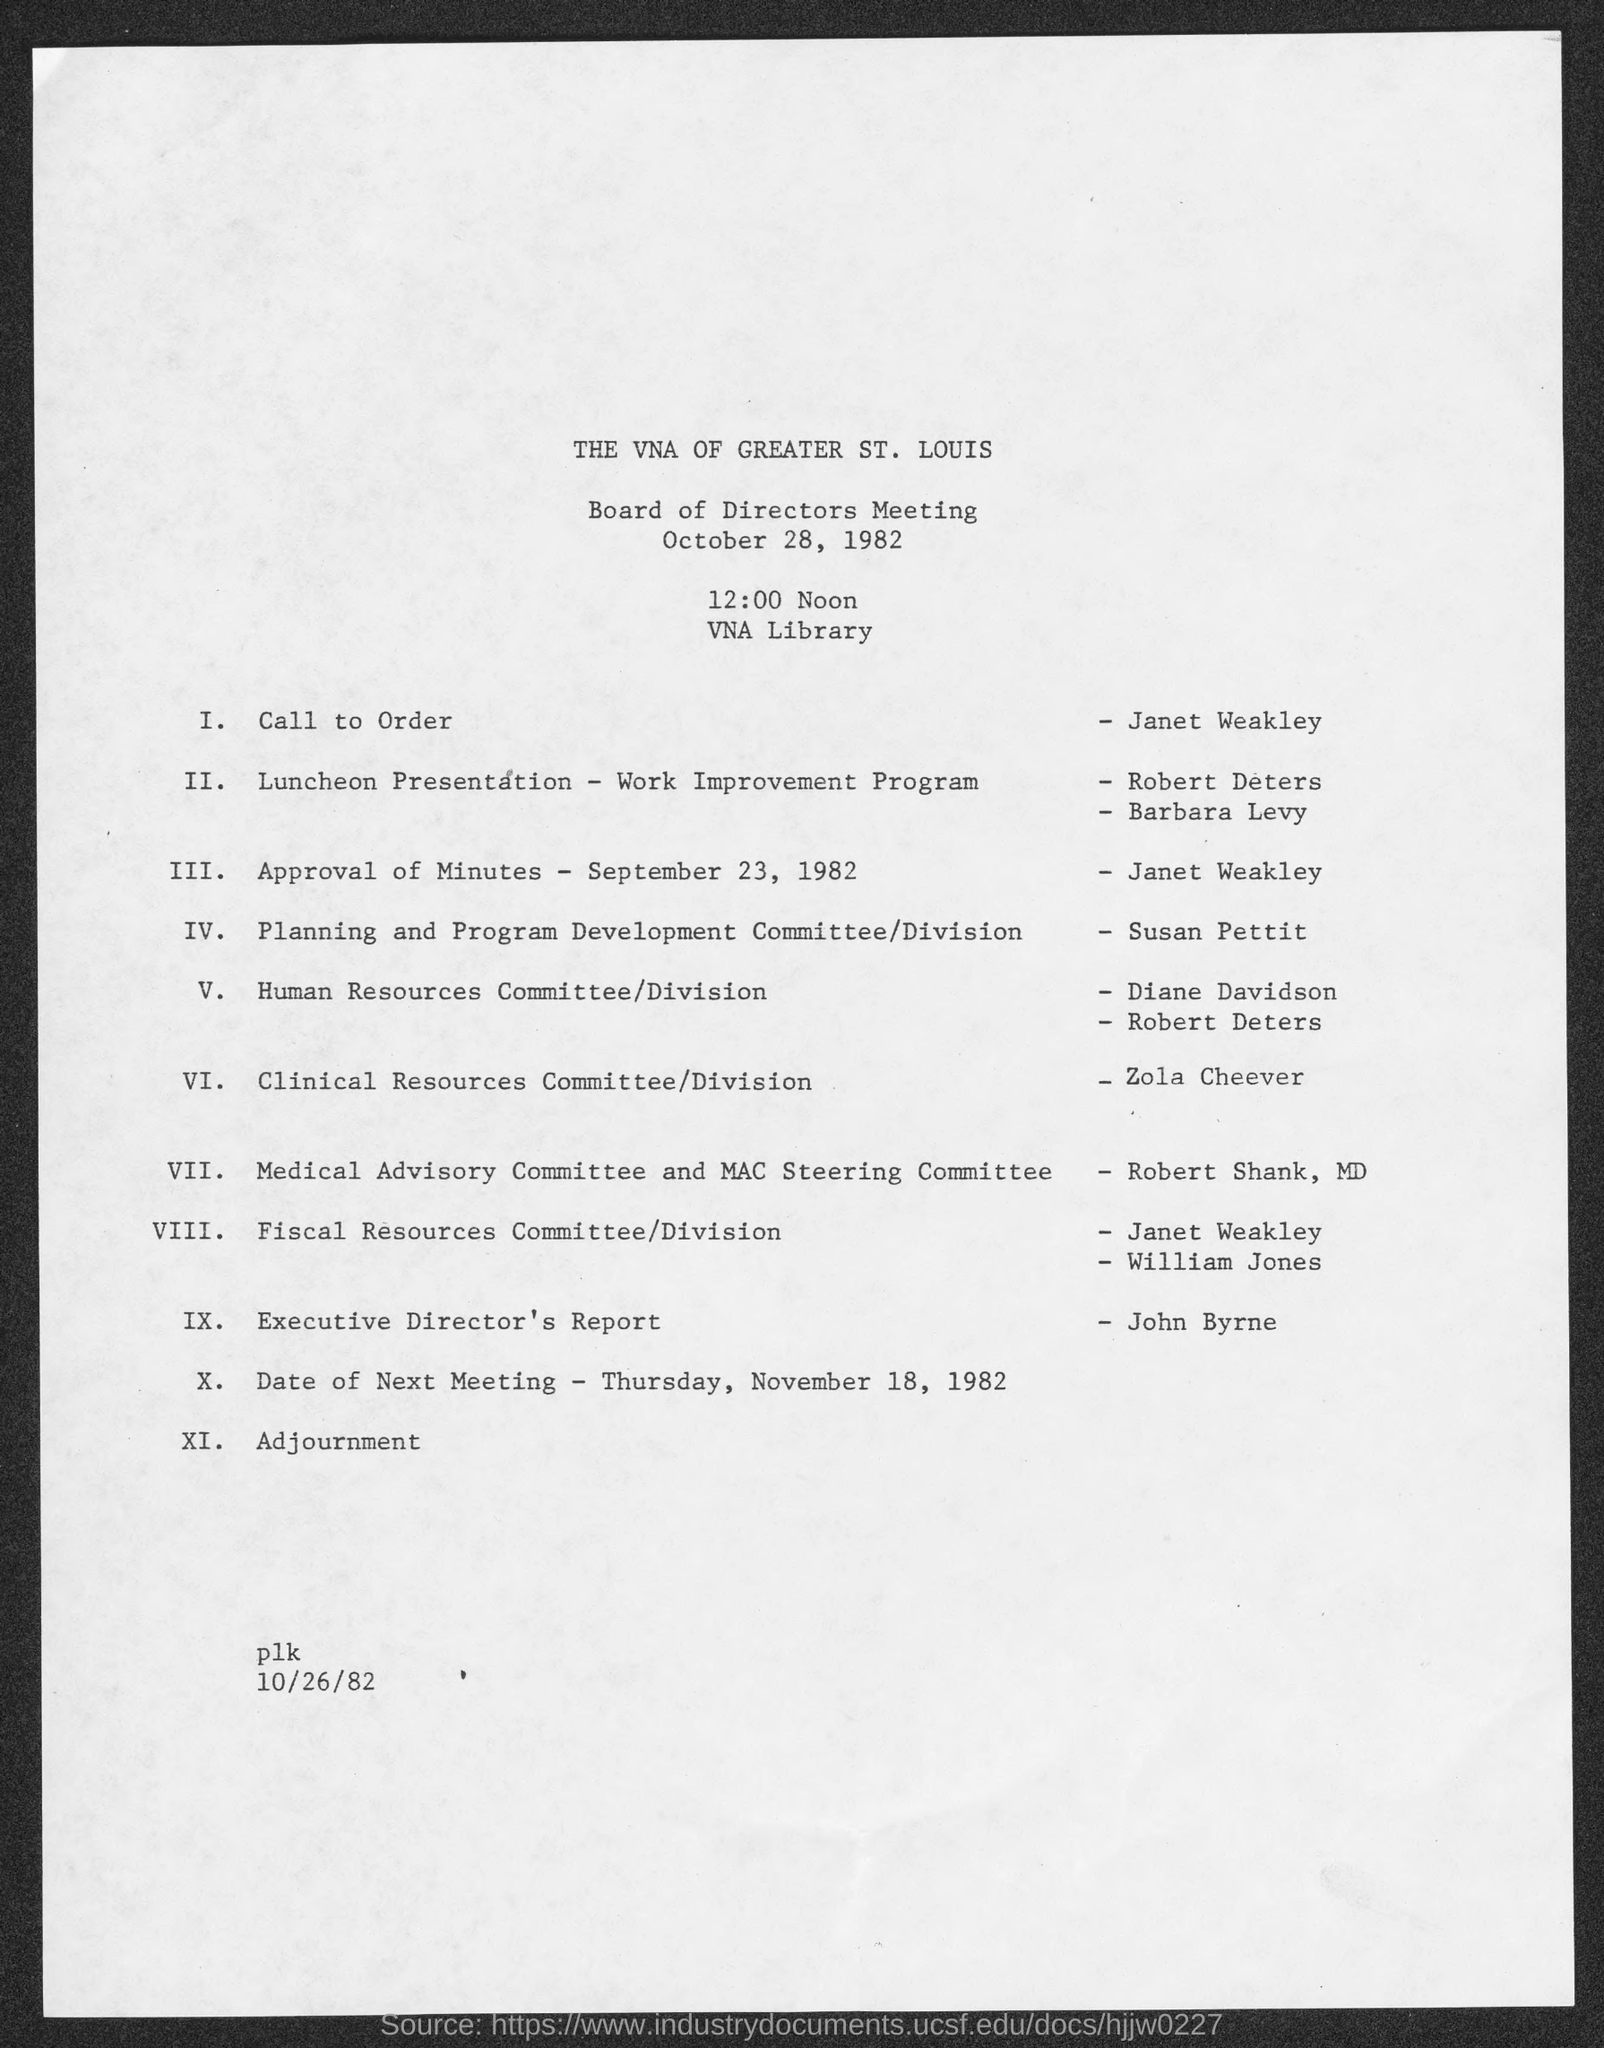Indicate a few pertinent items in this graphic. The Clinical Resources Committee/Division is headed by Zola Cheever. The call to order was given by Janet Weakley. The executive director's report was given by John Byrne. The date of approval for the minutes of September 23, 1982, has been established. The approval of the minutes of September 23, 1982, was given by Janet Weakley. 